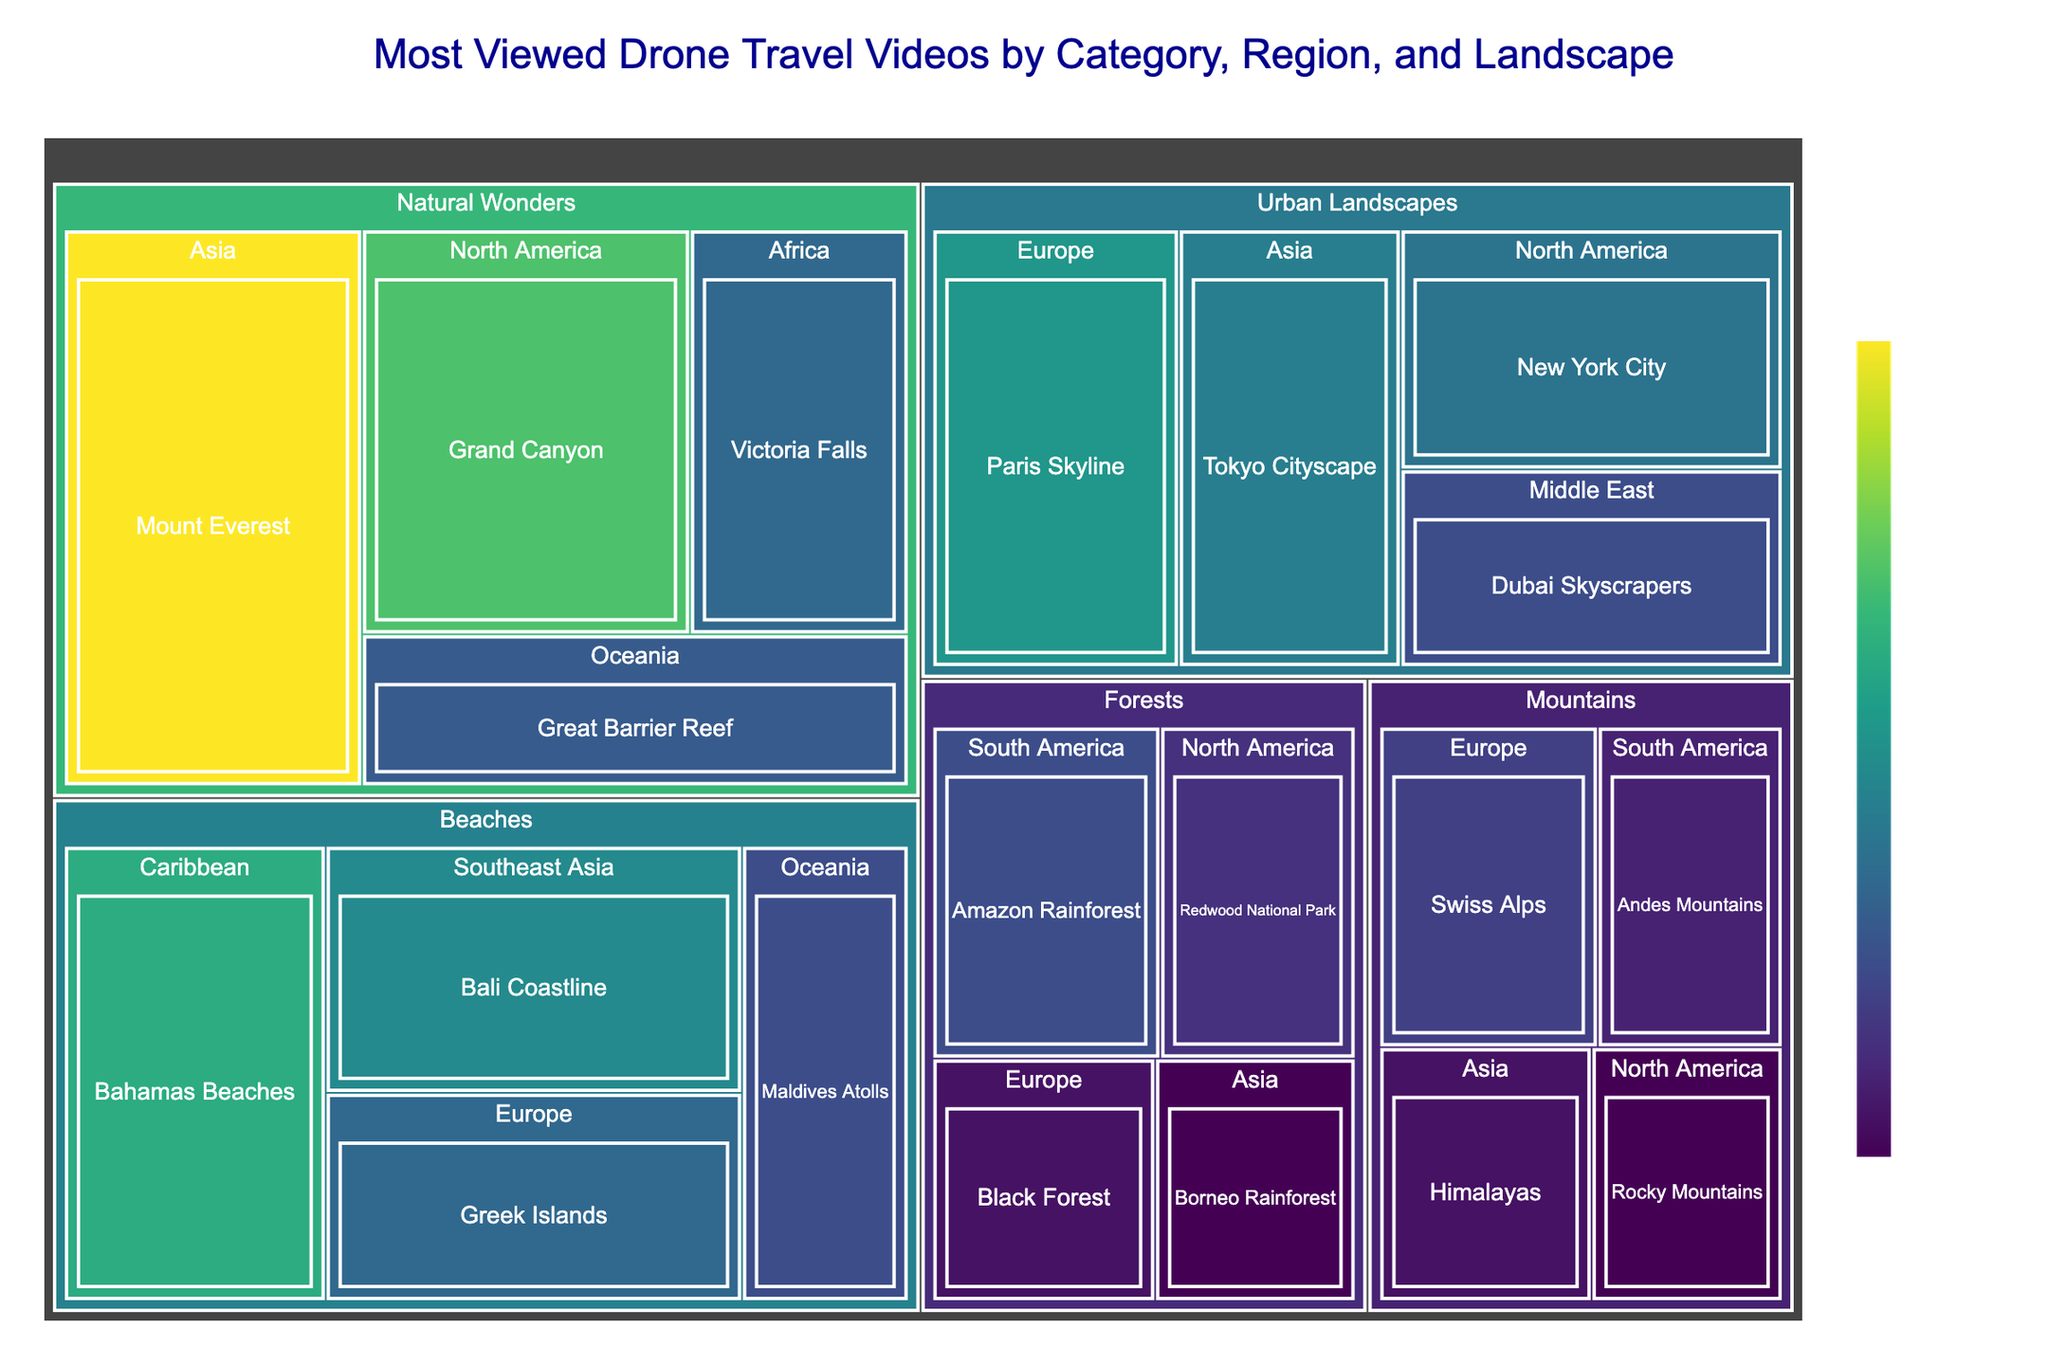What's the most viewed drone travel video? The most viewed video is represented by the largest segment on the treemap with the highest value in the 'Views' color scale.
Answer: Mount Everest in Asia with 15,000,000 views Which landscape feature in the Natural Wonders category has the least views? Look under the 'Natural Wonders' category and compare the views of each landscape feature.
Answer: Great Barrier Reef in Oceania with 7,500,000 views How many landscape features in the treemap have over 10 million views? Identify and count the segments with views greater than 10 million.
Answer: Three (Mount Everest, Grand Canyon, Bahamas Beaches) Which region has the highest combined views for its Urban Landscapes? Sum the views of the landscape features in each region under 'Urban Landscapes' and compare the totals.
Answer: Europe (Paris Skyline with 10,000,000 views, totaling 10,000,000 views) Compare the views of the Tokyo Cityscape and the New York City landscapes. Which one has more views and by how much? Subtract the views of New York City from the views of Tokyo Cityscape.
Answer: Tokyo Cityscape has 500,000 more views than New York City (9,000,000 - 8,500,000) Which category has the highest average number of views per landscape feature? Calculate the average views per landscape feature for each category, then compare these averages.
Answer: Natural Wonders (Average is (15,000,000 + 12,000,000 + 8,000,000 + 7,500,000) / 4 = 10,125,000) What is the total number of views for all drone videos in the Forests category? Sum the views of all landscape features in the 'Forests' category.
Answer: 22,500,000 views What is the least viewed landscape feature in the Mountains category? Look under 'Mountains' category and compare the views of each landscape feature.
Answer: Rocky Mountains in North America with 4,500,000 views How does the popularity of the Greek Islands compare to the Victoria Falls? Compare the views of the Greek Islands to those of the Victoria Falls to see which has more views and by how much.
Answer: Greek Islands have almost the same views but slightly lesser than Victoria Falls (8,000,000 vs. 8,000,000) In which geographical region are the drone travel videos most and least popular based on total views? Sum the total views for all landscape features in each region and identify the highest and lowest totals.
Answer: Most popular in Asia; least popular in Middle East 